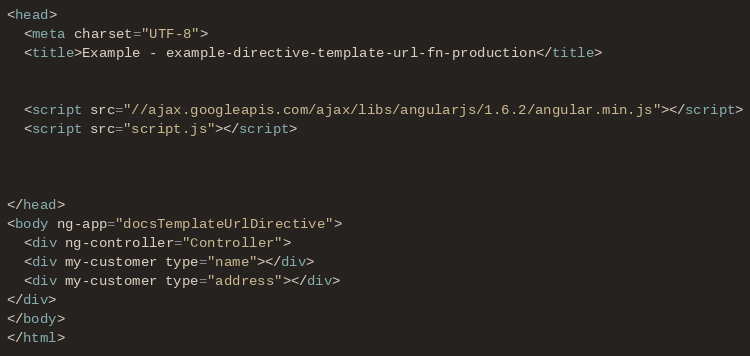Convert code to text. <code><loc_0><loc_0><loc_500><loc_500><_HTML_><head>
  <meta charset="UTF-8">
  <title>Example - example-directive-template-url-fn-production</title>
  

  <script src="//ajax.googleapis.com/ajax/libs/angularjs/1.6.2/angular.min.js"></script>
  <script src="script.js"></script>
  

  
</head>
<body ng-app="docsTemplateUrlDirective">
  <div ng-controller="Controller">
  <div my-customer type="name"></div>
  <div my-customer type="address"></div>
</div>
</body>
</html></code> 